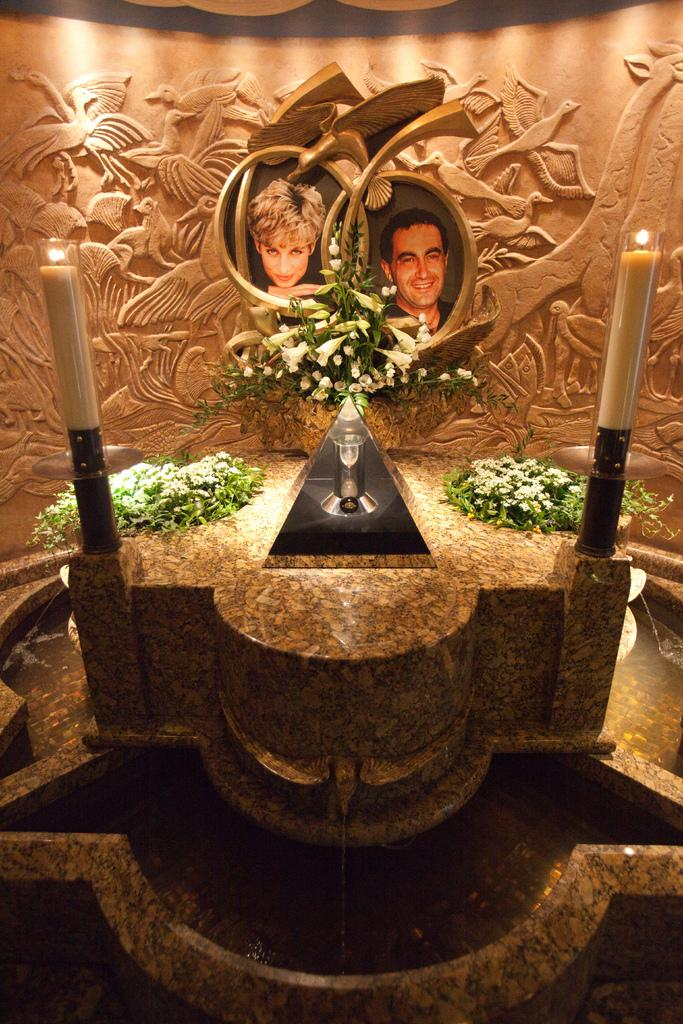What objects can be seen in the image that provide light? There are candles in the image that provide light. What is the liquid element present in the image? There is water in the image. What type of plant life is visible in the image? There are flowers in the image. Who are the people featured in the photos in the image? The photos in the image feature a man and a woman. What can be seen on the wall in the background of the image? There are designs on the wall in the background of the image. What type of grape is being used to cut the blade in the image? There is no grape or blade present in the image. What kind of pet can be seen interacting with the flowers in the image? There is no pet present in the image; only candles, water, flowers, photos, and a wall with designs are visible. 